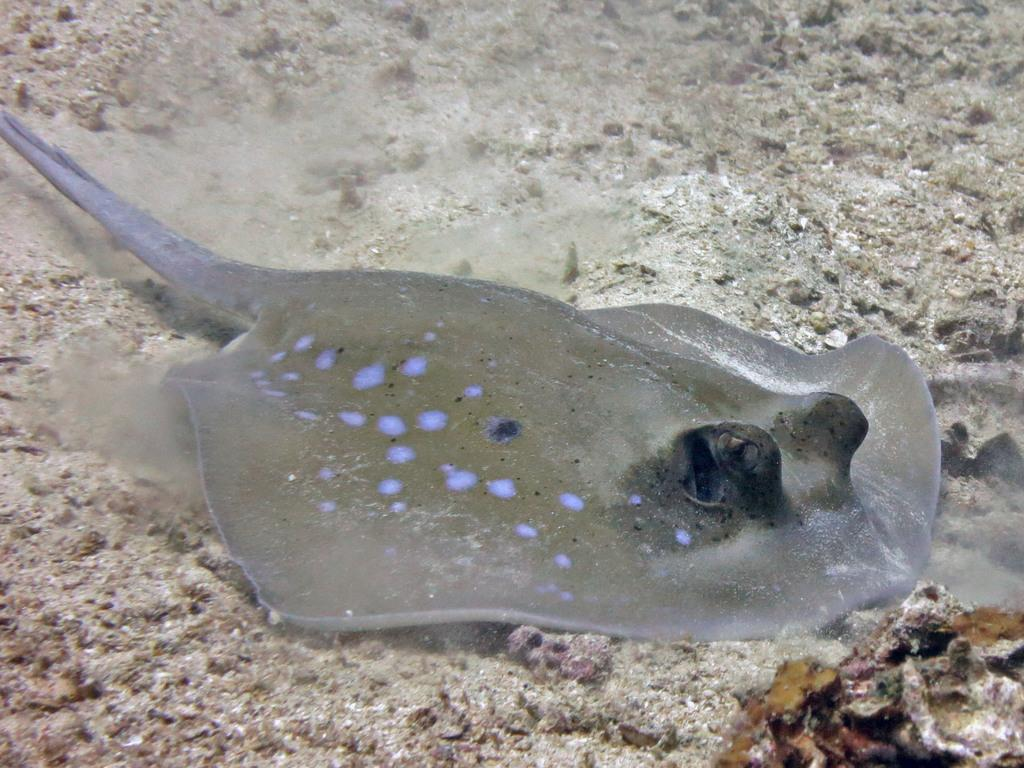What type of animal is in the image? There is a freshwater whipray in the image. Can you describe the appearance of the freshwater whipray? The freshwater whipray has a flat body, a long whip-like tail, and a distinctive diamond-shaped pattern on its back. What type of fabric is used to make the dress in the image? There is no dress present in the image; it features a freshwater whipray. 